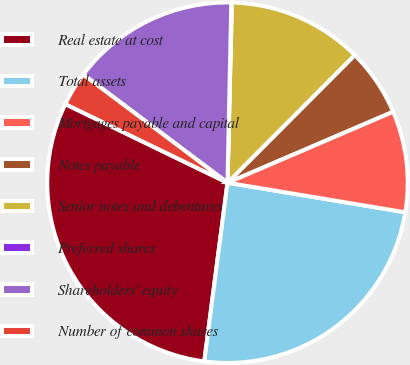Convert chart. <chart><loc_0><loc_0><loc_500><loc_500><pie_chart><fcel>Real estate at cost<fcel>Total assets<fcel>Mortgages payable and capital<fcel>Notes payable<fcel>Senior notes and debentures<fcel>Preferred shares<fcel>Shareholders' equity<fcel>Number of common shares<nl><fcel>30.13%<fcel>24.43%<fcel>9.08%<fcel>6.07%<fcel>12.09%<fcel>0.05%<fcel>15.09%<fcel>3.06%<nl></chart> 